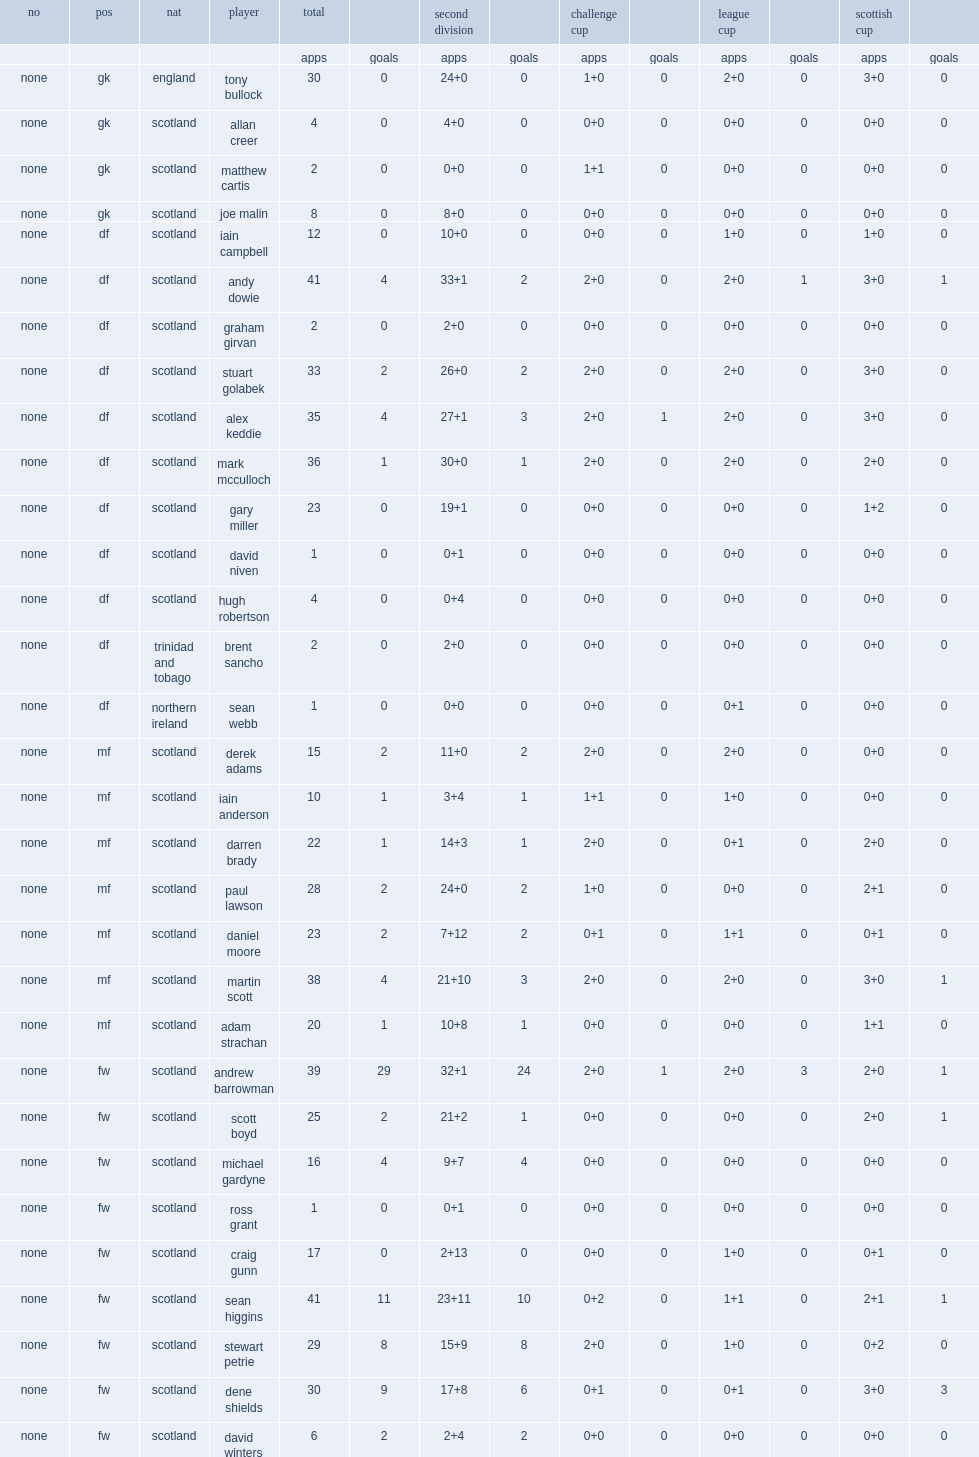List the matches that ross county f.c. season competed in. Challenge cup league cup scottish cup. 